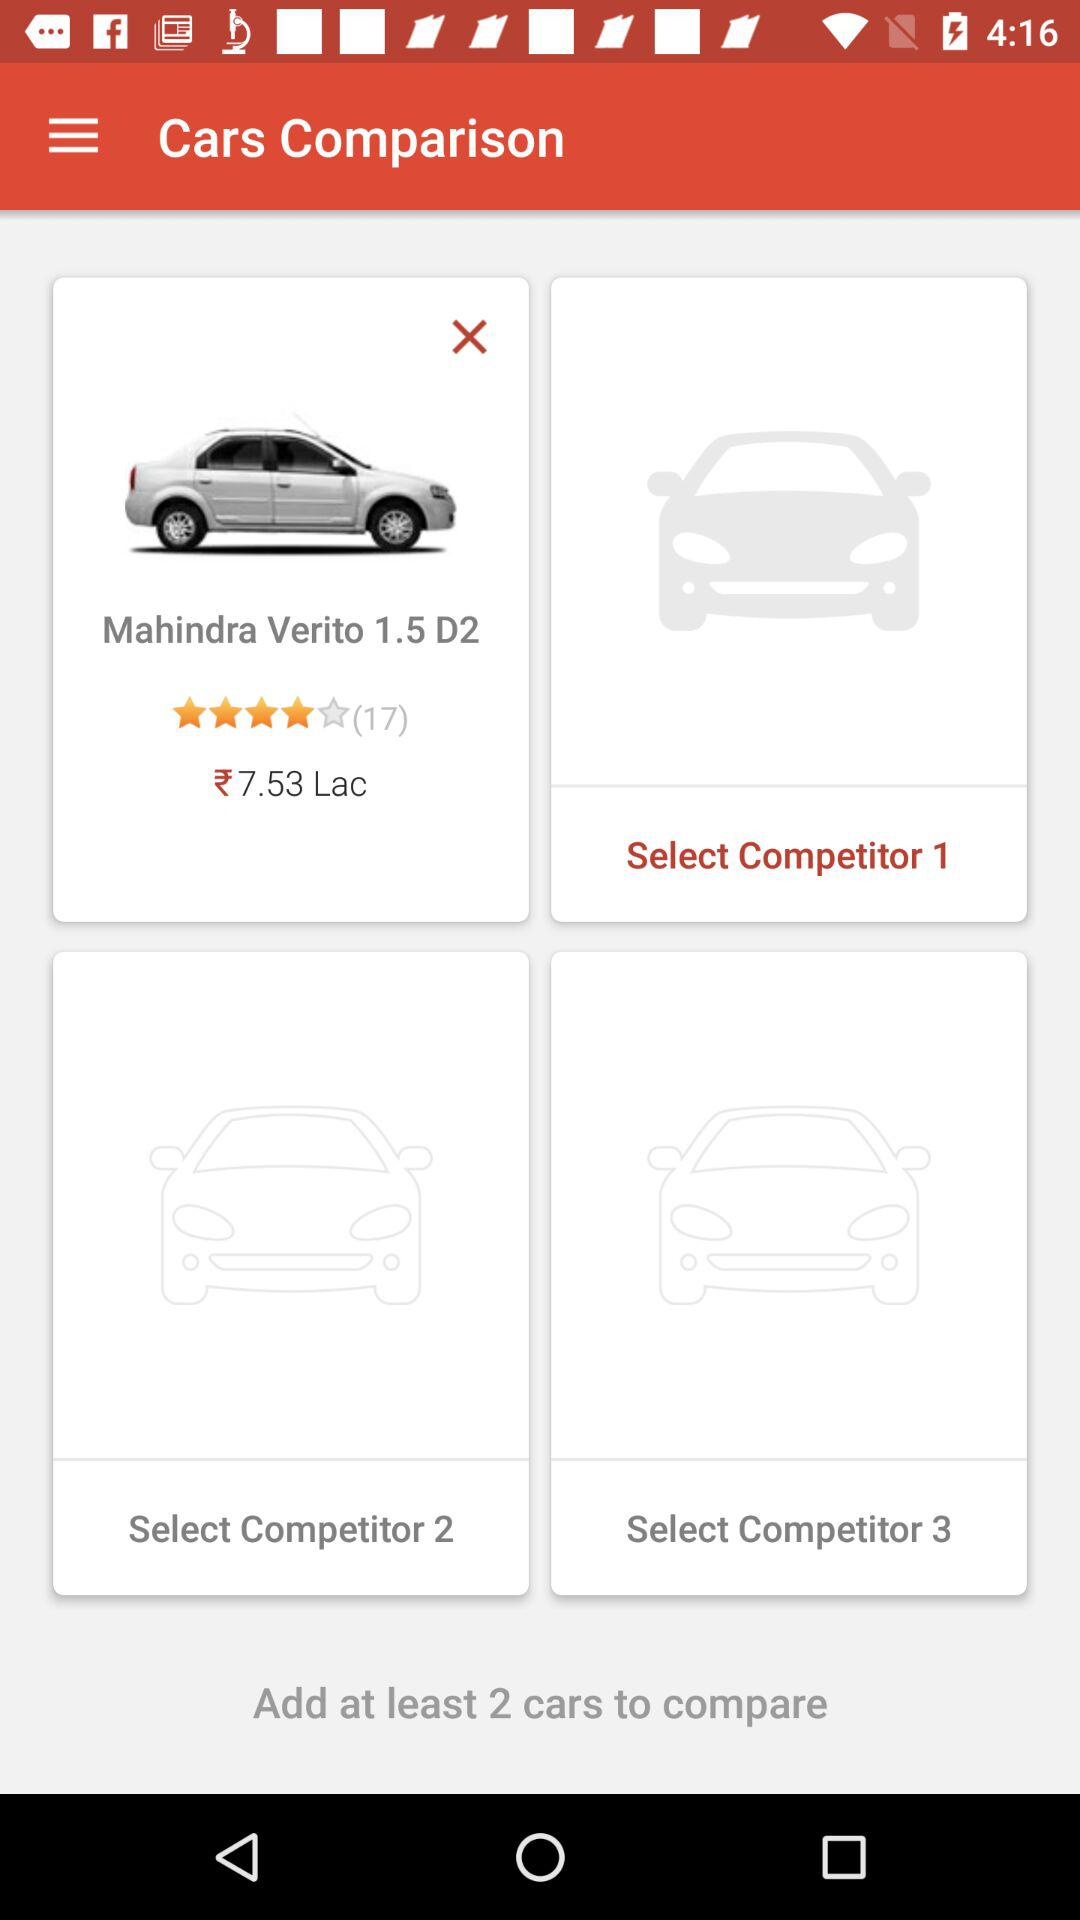How many cars do we need to include in the comparison? We need to include at least two cars in the comparison. 